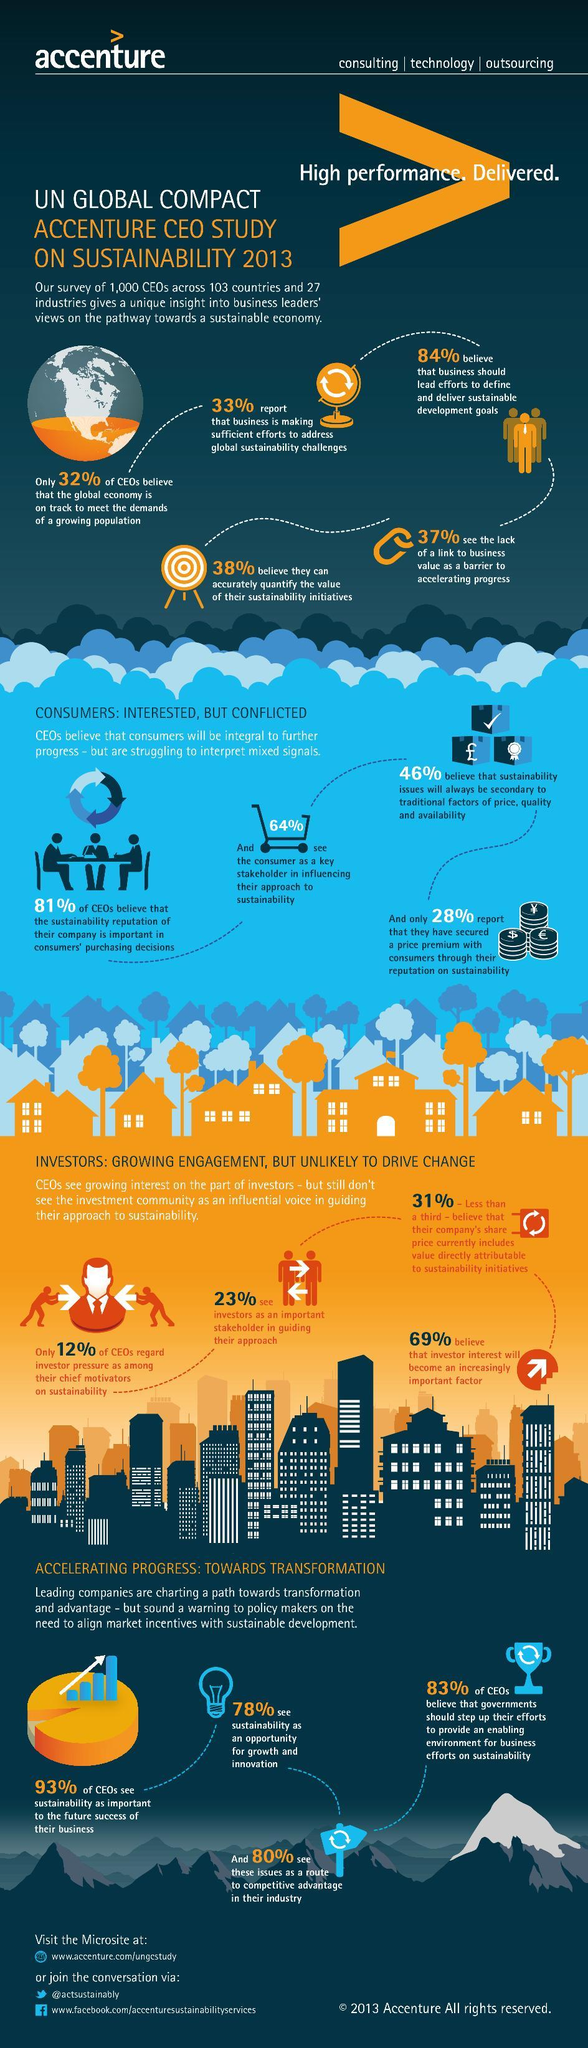What percentage of CEO's see the lack of a link to business value as a barrier to accelerating progress according to the survey?
Answer the question with a short phrase. 37% What percentage of CEO's didn't see the consumer as a key stakeholder in influencing their approach to sustainability according to the survey? 36% What percentage of CEO's see sustainability as an opportunity for growth and innovation according to the survey? 78% What percentage of CEO's didn't see sustainability as important to the future success of their business according to the survey? 7% 